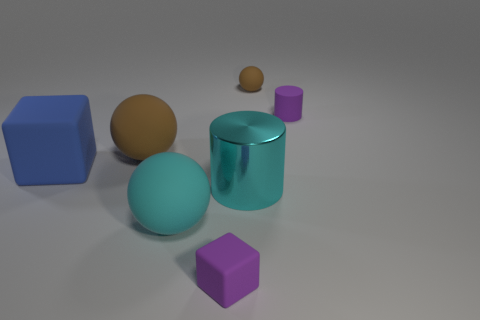What is the color of the large rubber object that is in front of the large brown rubber ball and behind the cyan cylinder?
Offer a terse response. Blue. There is a brown rubber thing behind the small purple rubber cylinder on the right side of the large brown rubber ball; what size is it?
Your answer should be compact. Small. Are there any small matte cubes of the same color as the small cylinder?
Your answer should be compact. Yes. Are there an equal number of brown matte things that are to the left of the purple cube and blue rubber balls?
Ensure brevity in your answer.  No. What number of rubber balls are there?
Give a very brief answer. 3. What shape is the large matte thing that is both behind the big cyan shiny cylinder and on the right side of the blue rubber object?
Provide a succinct answer. Sphere. Do the small thing in front of the big blue rubber block and the ball that is on the right side of the cyan cylinder have the same color?
Your answer should be compact. No. There is a matte sphere that is the same color as the shiny cylinder; what is its size?
Your answer should be compact. Large. Is there a tiny purple cylinder made of the same material as the big cyan cylinder?
Your response must be concise. No. Are there an equal number of blue rubber cubes that are behind the blue rubber block and big matte balls in front of the cyan cylinder?
Your response must be concise. No. 